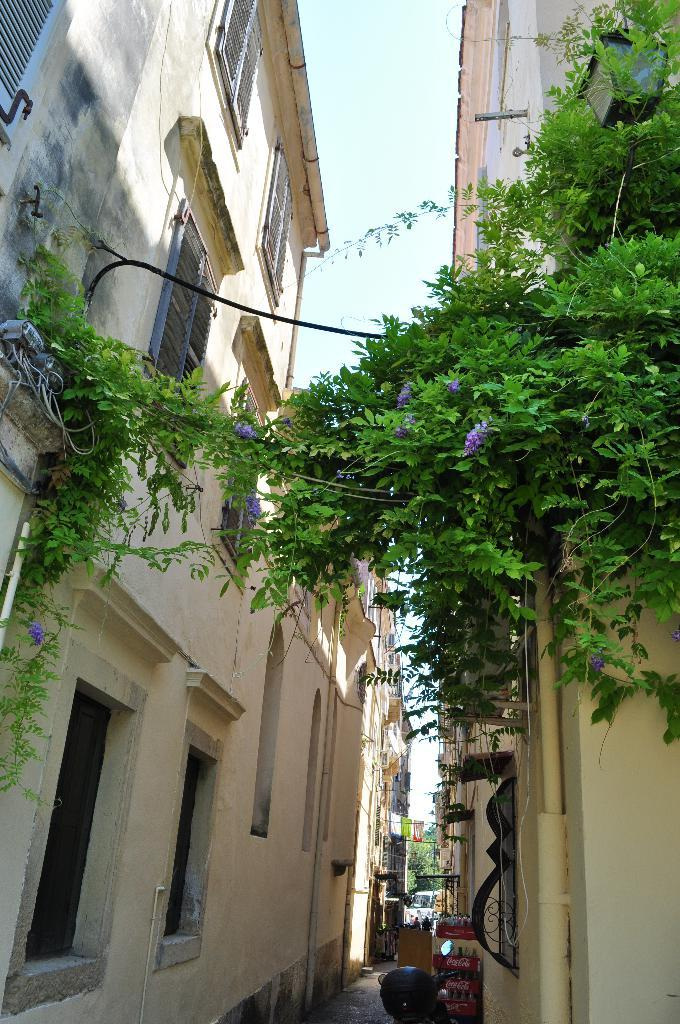Where was the image taken? The image is taken outdoors. What can be seen at the top of the image? The sky is visible at the top of the image. What is present on both sides of the image? There are buildings on the left and right sides of the image. What are the main features of the buildings in the image? The buildings have walls, windows, roofs, and doors. What type of powder is being used to create the buildings in the image? There is no indication that the buildings in the image were created using powder; they appear to be solid structures. How does the pail fit into the scene depicted in the image? There is no pail present in the image. 